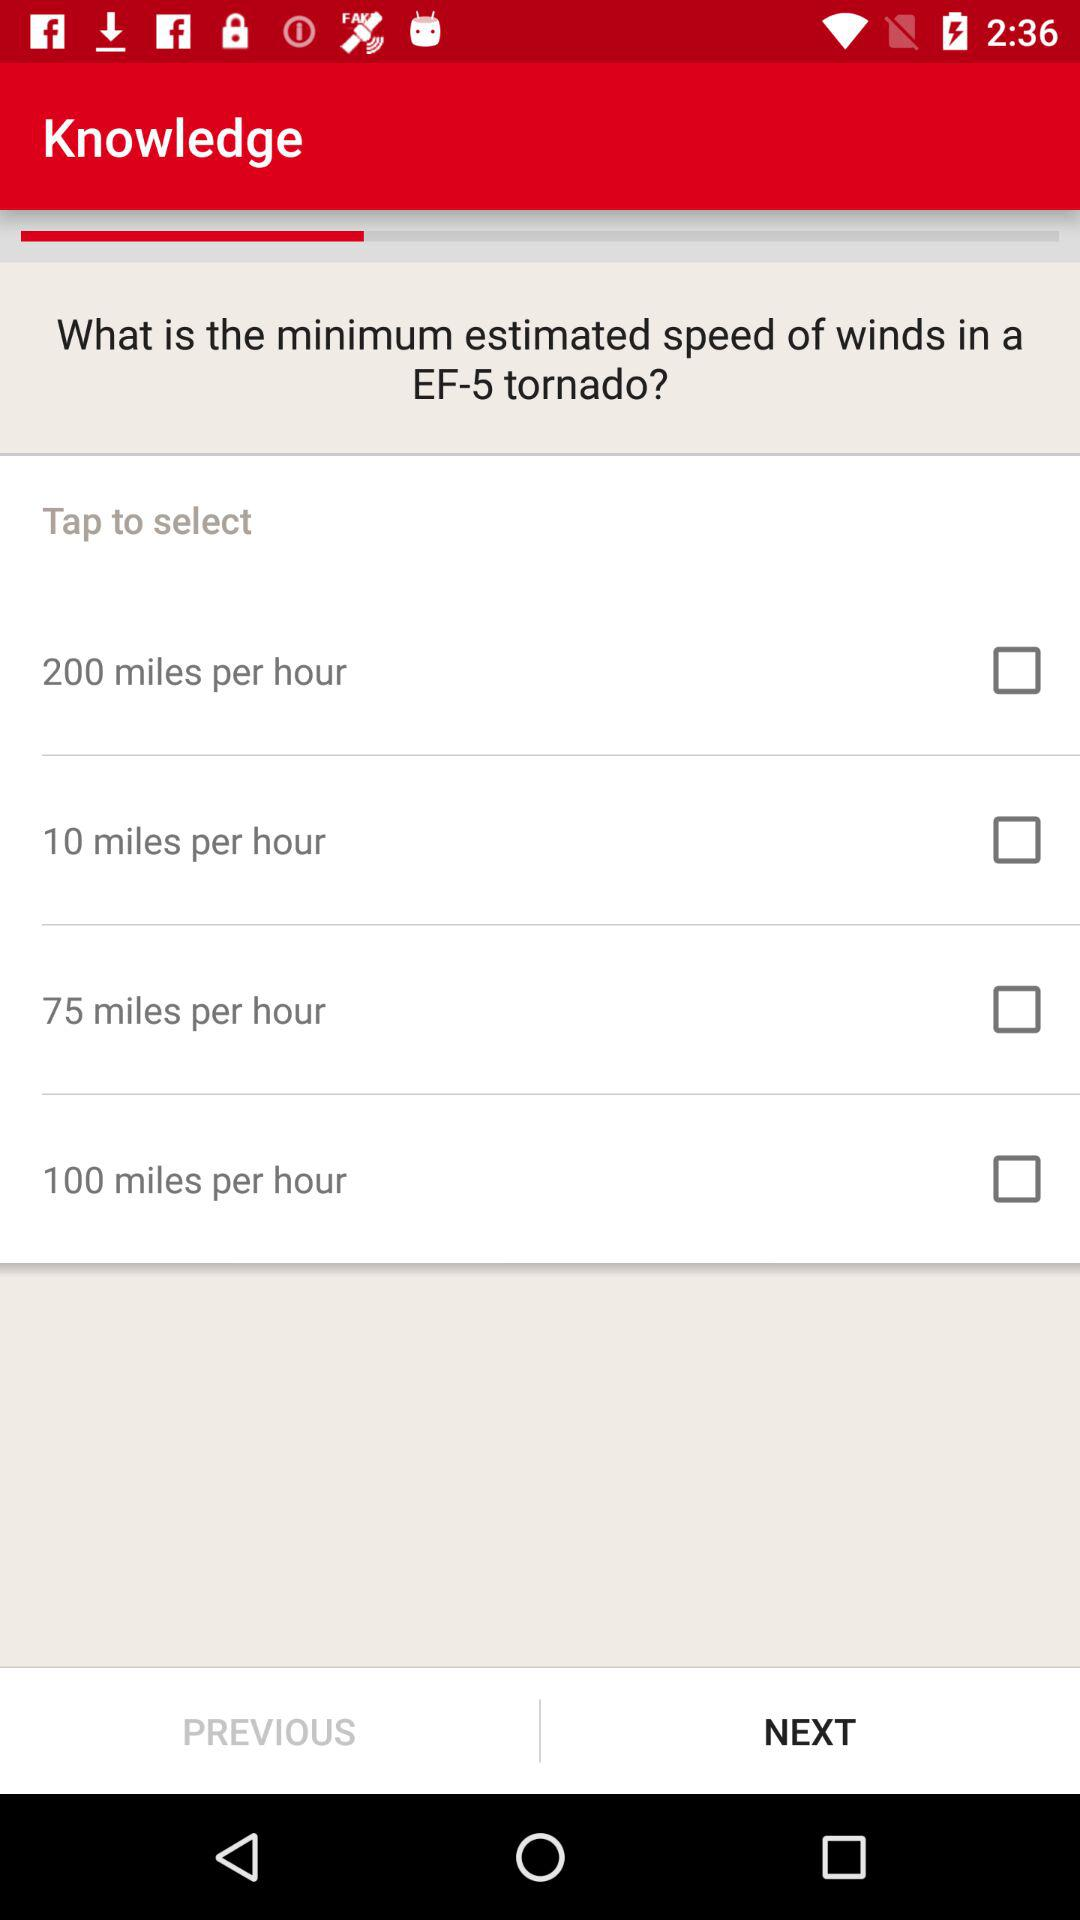How many options are there for the minimum estimated speed of winds in an EF-5 tornado?
Answer the question using a single word or phrase. 4 